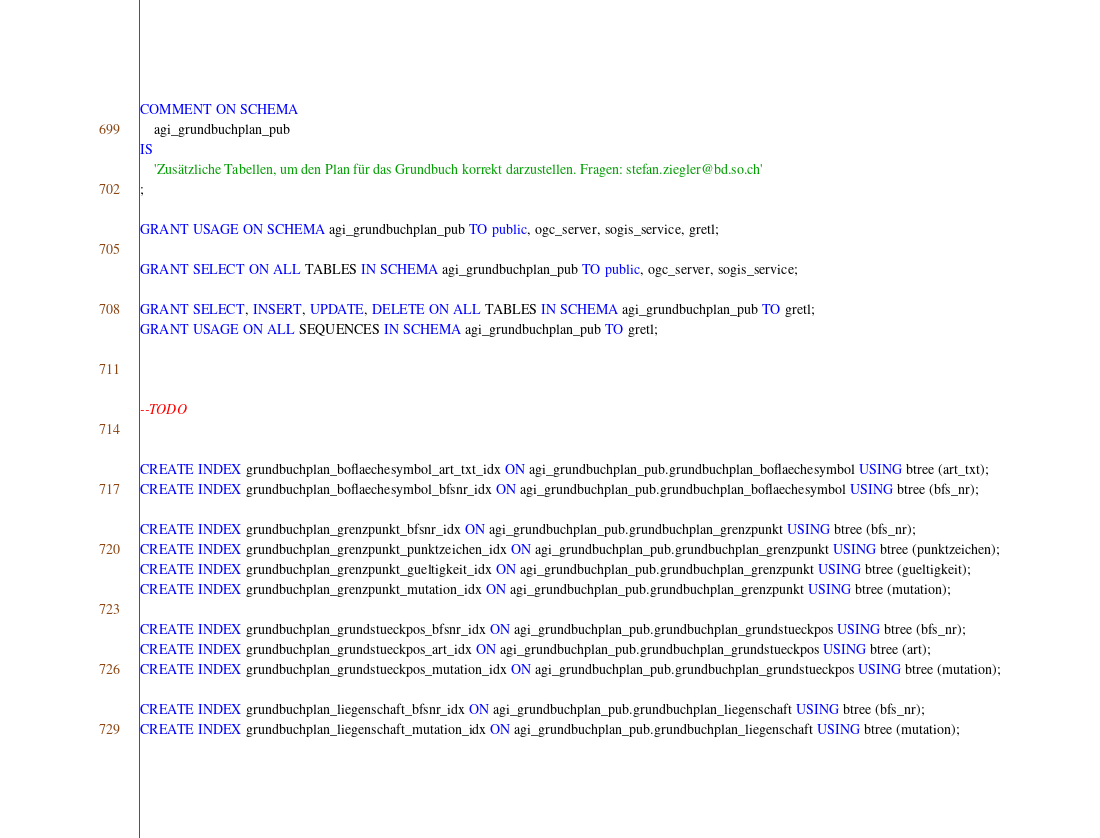Convert code to text. <code><loc_0><loc_0><loc_500><loc_500><_SQL_>COMMENT ON SCHEMA
    agi_grundbuchplan_pub
IS
    'Zusätzliche Tabellen, um den Plan für das Grundbuch korrekt darzustellen. Fragen: stefan.ziegler@bd.so.ch'
;

GRANT USAGE ON SCHEMA agi_grundbuchplan_pub TO public, ogc_server, sogis_service, gretl;

GRANT SELECT ON ALL TABLES IN SCHEMA agi_grundbuchplan_pub TO public, ogc_server, sogis_service;

GRANT SELECT, INSERT, UPDATE, DELETE ON ALL TABLES IN SCHEMA agi_grundbuchplan_pub TO gretl;
GRANT USAGE ON ALL SEQUENCES IN SCHEMA agi_grundbuchplan_pub TO gretl;



--TODO


CREATE INDEX grundbuchplan_boflaechesymbol_art_txt_idx ON agi_grundbuchplan_pub.grundbuchplan_boflaechesymbol USING btree (art_txt);
CREATE INDEX grundbuchplan_boflaechesymbol_bfsnr_idx ON agi_grundbuchplan_pub.grundbuchplan_boflaechesymbol USING btree (bfs_nr);

CREATE INDEX grundbuchplan_grenzpunkt_bfsnr_idx ON agi_grundbuchplan_pub.grundbuchplan_grenzpunkt USING btree (bfs_nr);
CREATE INDEX grundbuchplan_grenzpunkt_punktzeichen_idx ON agi_grundbuchplan_pub.grundbuchplan_grenzpunkt USING btree (punktzeichen);
CREATE INDEX grundbuchplan_grenzpunkt_gueltigkeit_idx ON agi_grundbuchplan_pub.grundbuchplan_grenzpunkt USING btree (gueltigkeit);
CREATE INDEX grundbuchplan_grenzpunkt_mutation_idx ON agi_grundbuchplan_pub.grundbuchplan_grenzpunkt USING btree (mutation);

CREATE INDEX grundbuchplan_grundstueckpos_bfsnr_idx ON agi_grundbuchplan_pub.grundbuchplan_grundstueckpos USING btree (bfs_nr);
CREATE INDEX grundbuchplan_grundstueckpos_art_idx ON agi_grundbuchplan_pub.grundbuchplan_grundstueckpos USING btree (art);
CREATE INDEX grundbuchplan_grundstueckpos_mutation_idx ON agi_grundbuchplan_pub.grundbuchplan_grundstueckpos USING btree (mutation);

CREATE INDEX grundbuchplan_liegenschaft_bfsnr_idx ON agi_grundbuchplan_pub.grundbuchplan_liegenschaft USING btree (bfs_nr);
CREATE INDEX grundbuchplan_liegenschaft_mutation_idx ON agi_grundbuchplan_pub.grundbuchplan_liegenschaft USING btree (mutation);
</code> 